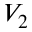<formula> <loc_0><loc_0><loc_500><loc_500>V _ { 2 }</formula> 